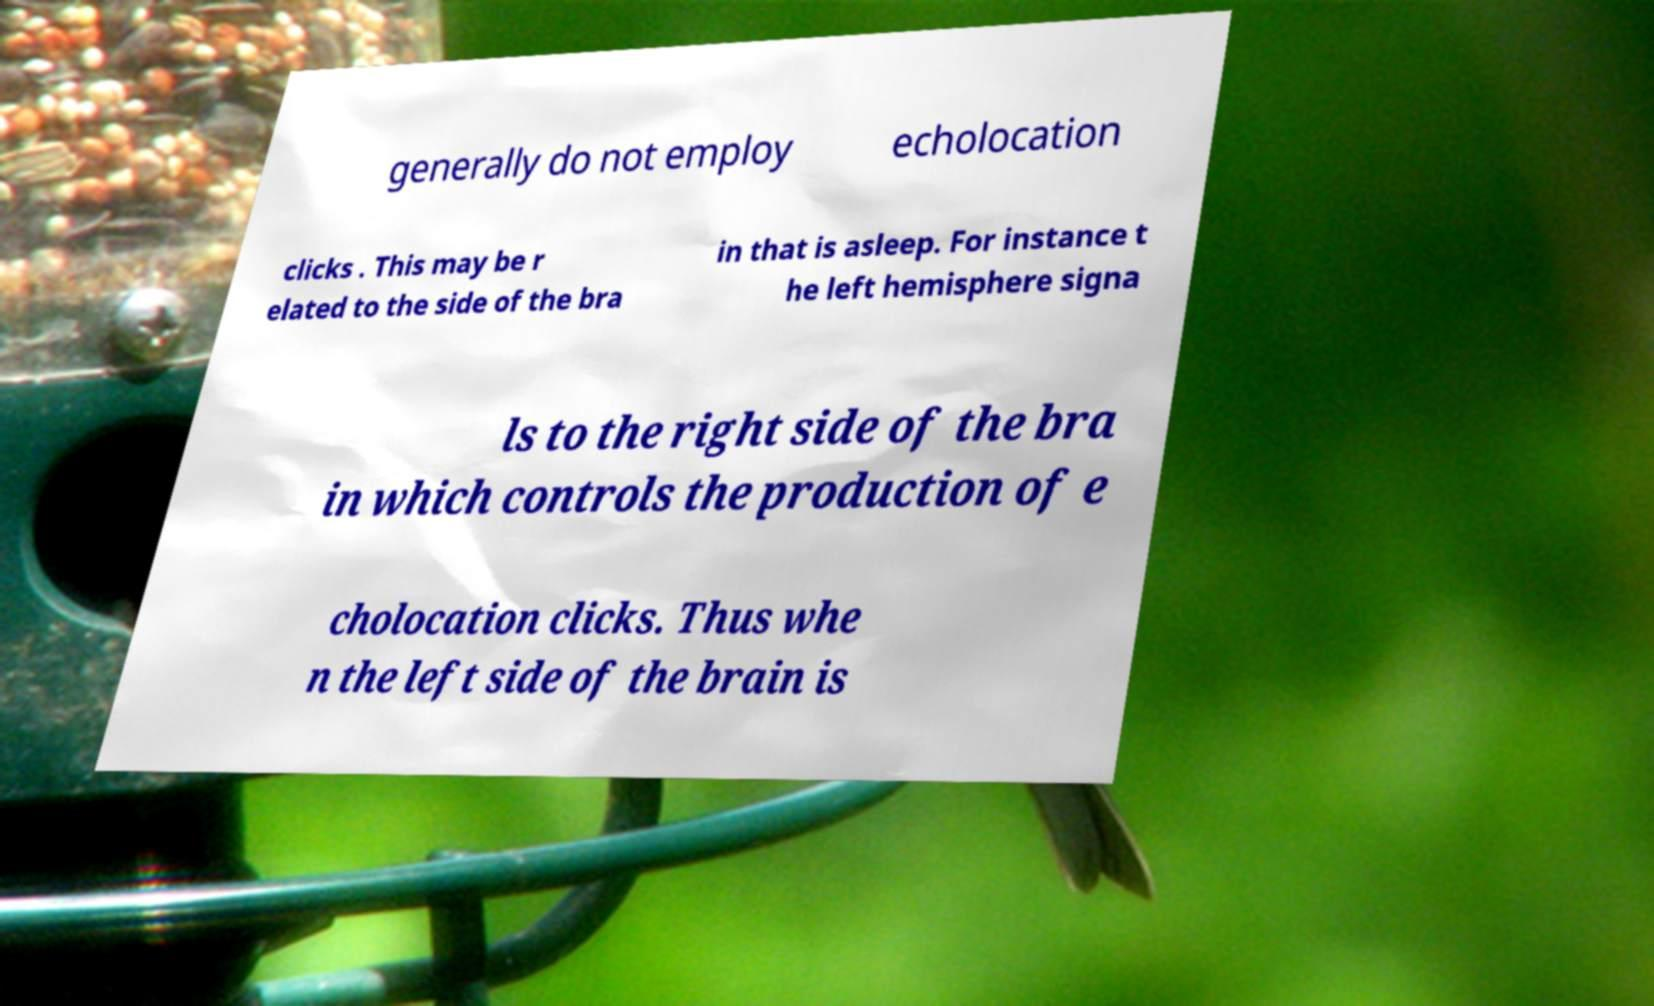There's text embedded in this image that I need extracted. Can you transcribe it verbatim? generally do not employ echolocation clicks . This may be r elated to the side of the bra in that is asleep. For instance t he left hemisphere signa ls to the right side of the bra in which controls the production of e cholocation clicks. Thus whe n the left side of the brain is 